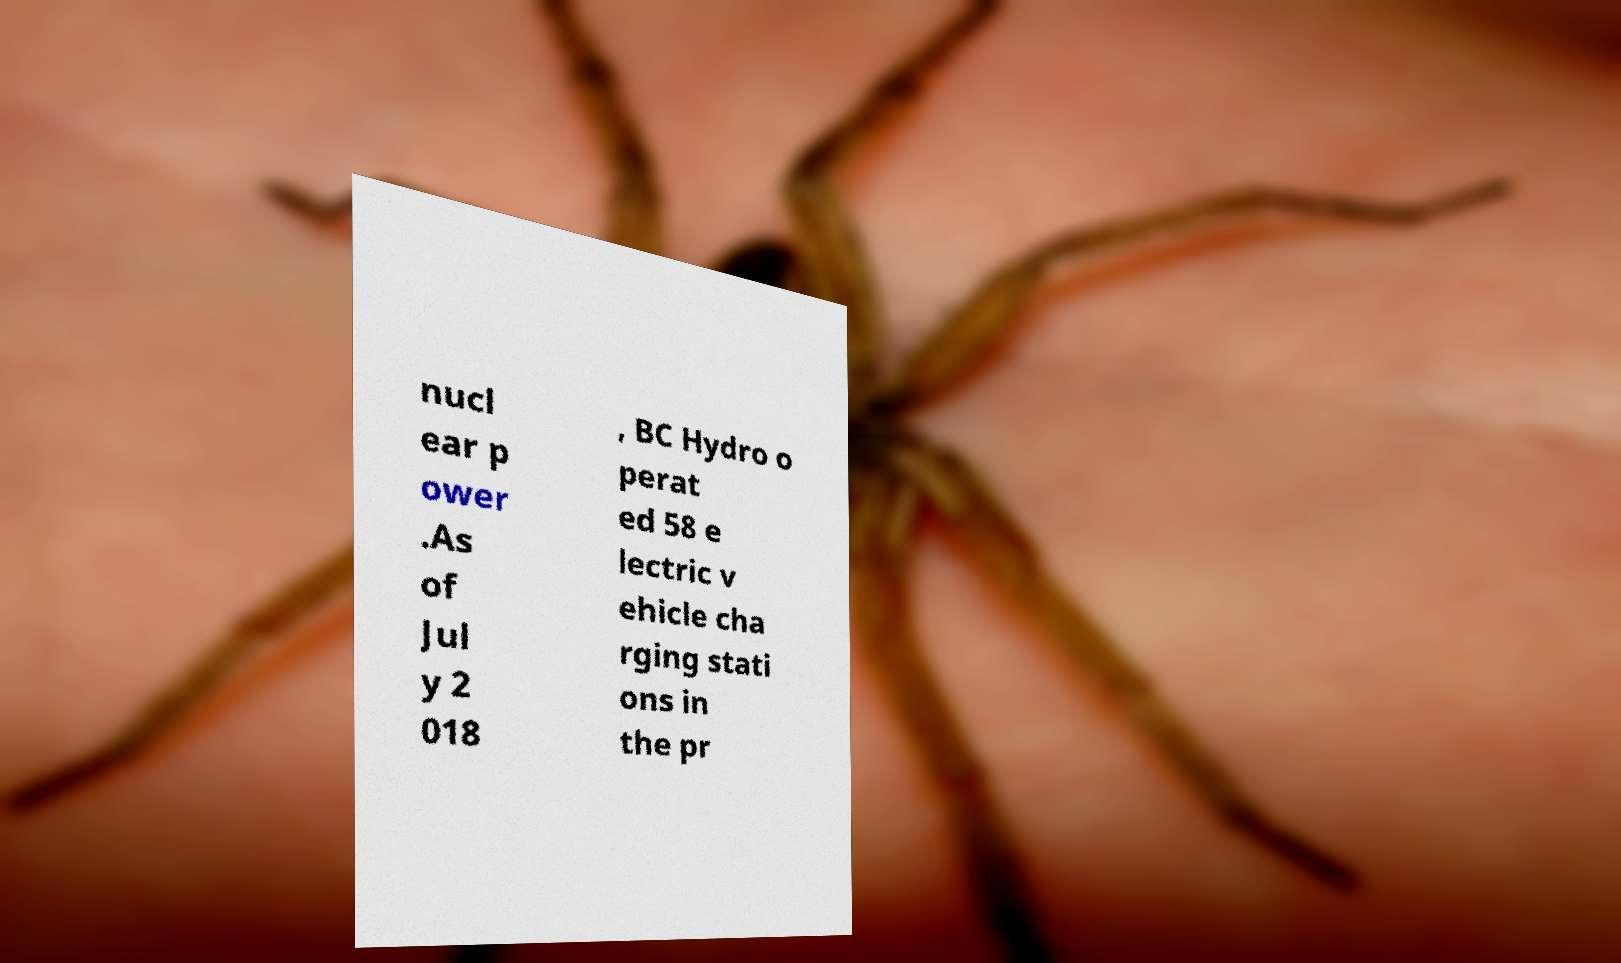Can you read and provide the text displayed in the image?This photo seems to have some interesting text. Can you extract and type it out for me? nucl ear p ower .As of Jul y 2 018 , BC Hydro o perat ed 58 e lectric v ehicle cha rging stati ons in the pr 